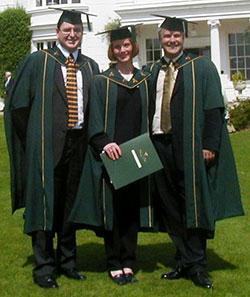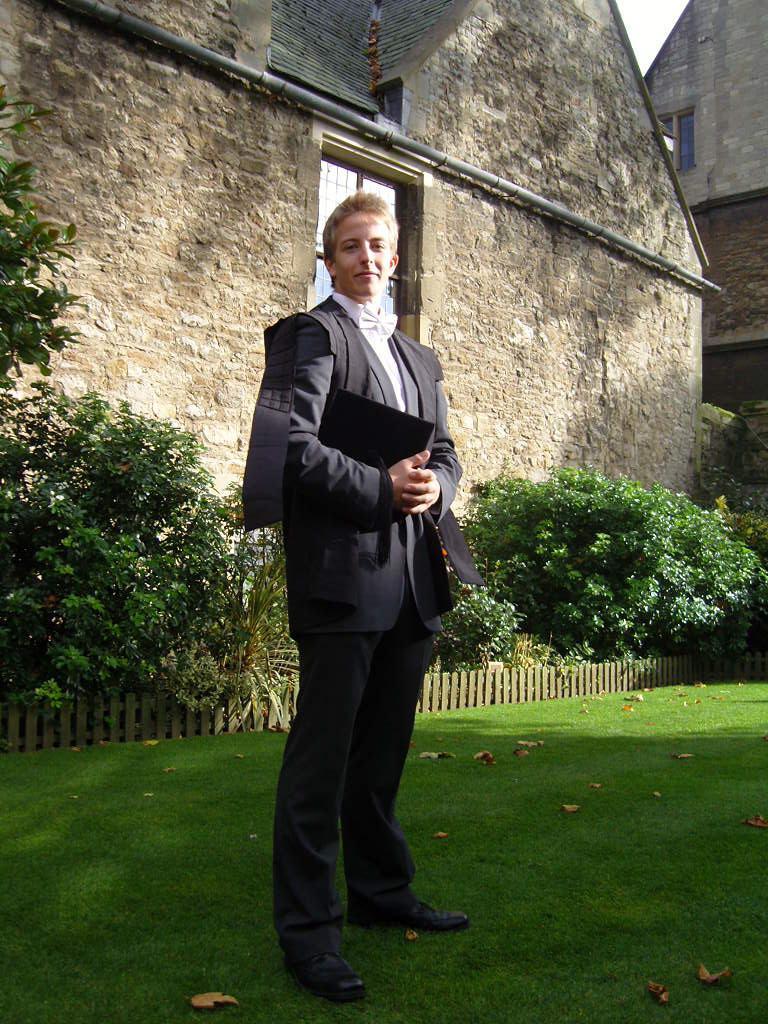The first image is the image on the left, the second image is the image on the right. Examine the images to the left and right. Is the description "An image contains more than one graduation student." accurate? Answer yes or no. Yes. The first image is the image on the left, the second image is the image on the right. Given the left and right images, does the statement "An image shows only one person modeling graduation attire, a long-haired female who is not facing the camera." hold true? Answer yes or no. No. 